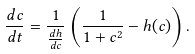Convert formula to latex. <formula><loc_0><loc_0><loc_500><loc_500>\frac { d c } { d t } = \frac { 1 } { \frac { d h } { d c } } \left ( \frac { 1 } { 1 + c ^ { 2 } } - h ( c ) \right ) .</formula> 